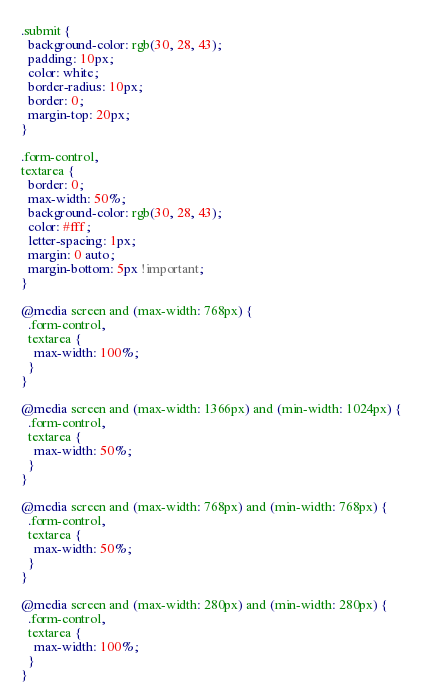Convert code to text. <code><loc_0><loc_0><loc_500><loc_500><_CSS_>.submit {
  background-color: rgb(30, 28, 43);
  padding: 10px;
  color: white;
  border-radius: 10px;
  border: 0;
  margin-top: 20px;
}

.form-control,
textarea {
  border: 0;
  max-width: 50%;
  background-color: rgb(30, 28, 43);
  color: #fff;
  letter-spacing: 1px;
  margin: 0 auto;
  margin-bottom: 5px !important;
}

@media screen and (max-width: 768px) {
  .form-control,
  textarea {
    max-width: 100%;
  }
}

@media screen and (max-width: 1366px) and (min-width: 1024px) {
  .form-control,
  textarea {
    max-width: 50%;
  }
}

@media screen and (max-width: 768px) and (min-width: 768px) {
  .form-control,
  textarea {
    max-width: 50%;
  }
}

@media screen and (max-width: 280px) and (min-width: 280px) {
  .form-control,
  textarea {
    max-width: 100%;
  }
}
</code> 